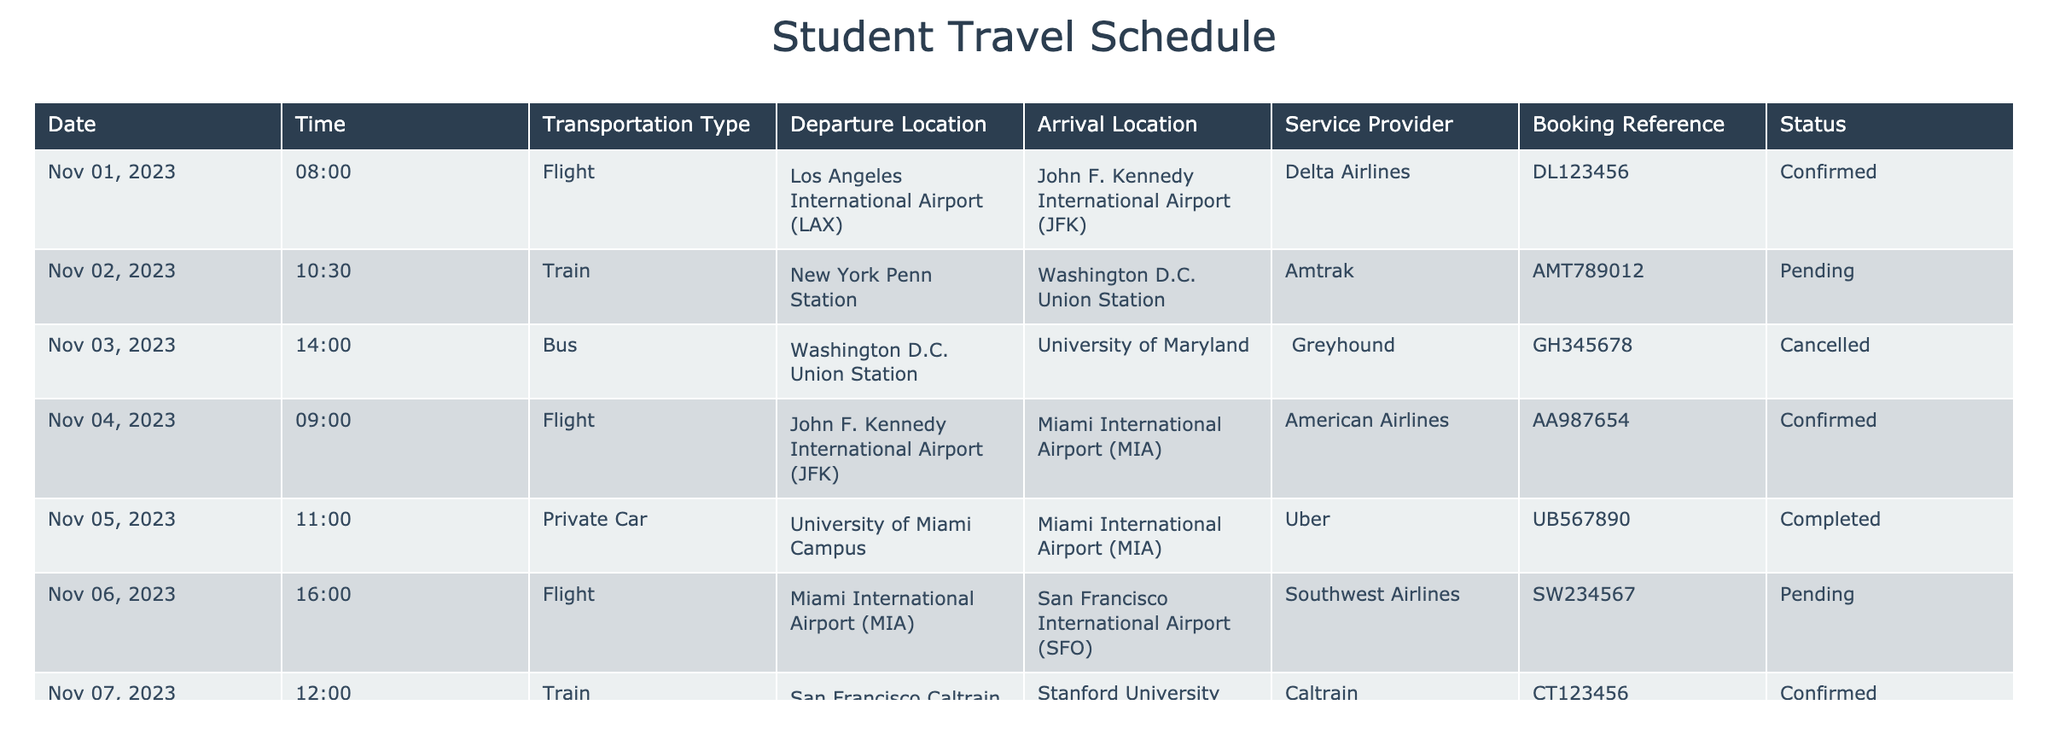What is the status of the flight from Los Angeles International Airport to John F. Kennedy International Airport? The table clearly shows that the flight on November 1, 2023, has a status labeled as "Confirmed."
Answer: Confirmed How many different types of transportation are listed in the schedule? The table lists four types of transportation: Flight, Train, Bus, and Private Car. Upon reviewing the "Transportation Type" column, we identify these four unique categories.
Answer: Four Is there a confirmed train service on November 7, 2023? Yes, on November 7, 2023, a train service is scheduled from San Francisco Caltrain Station to Stanford University, and its status is "Confirmed."
Answer: Yes What is the total number of transportation arrangements that are confirmed? By reviewing the table, we see that there are four confirmed arrangements: the flight on November 1, the flight on November 4, the train on November 7, and the flight on November 8. Summing these gives us a total of four confirmed arrangements.
Answer: Four Did any transportation arrangements get cancelled? Yes, there is one transportation arrangement that was cancelled; the bus service on November 3, 2023, from Washington D.C. Union Station to the University of Maryland is marked as "Cancelled."
Answer: Yes What is the difference in transportation types for arrangements that are confirmed versus those that are pending? Confirmed arrangements include Flights (3), a Train (1), while pending arrangements consist of a Flight (1) and a Train (1). This involves identifying the types in each status and counting them. The confirmed arrangements include more flight options, totaling four, while the pending arrangements include two, of which one is a flight.
Answer: Confirmed arrangements have more types What time is the bus scheduled to arrive at the University of Maryland? The bus was scheduled to depart at 14:00 on November 3, 2023, but it was ultimately cancelled; thus, no arrival time can be provided.
Answer: N/A What is the booking reference for the complete private car service? The table indicates that the private car service on November 5, 2023, has a booking reference of "UB567890." Reviewing the corresponding details in the table confirms this information.
Answer: UB567890 How many total unique departure locations are listed in the schedule? The departure locations include Los Angeles International Airport, New York Penn Station, Washington D.C. Union Station, John F. Kennedy International Airport, University of Miami Campus, Miami International Airport, and San Francisco International Airport. Counting these gives a total of seven unique departure locations present in the table.
Answer: Seven 